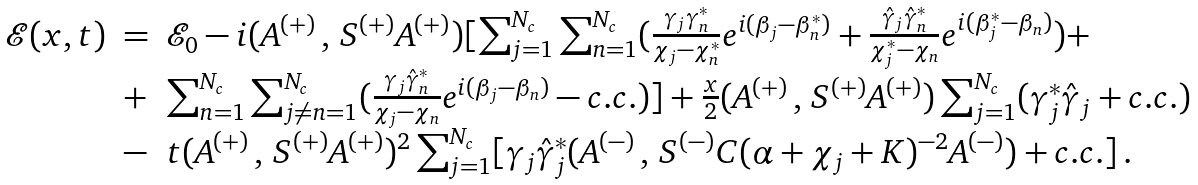<formula> <loc_0><loc_0><loc_500><loc_500>\begin{array} { l l l } \mathcal { E } ( x , t ) & = & \mathcal { E } _ { 0 } - i ( A ^ { ( + ) } \, , \, S ^ { ( + ) } A ^ { ( + ) } ) [ \sum _ { j = 1 } ^ { N _ { c } } \sum _ { n = 1 } ^ { N _ { c } } ( \frac { \gamma _ { j } \gamma _ { n } ^ { * } } { \chi _ { j } - \chi _ { n } ^ { * } } e ^ { i ( \beta _ { j } - \beta _ { n } ^ { * } ) } + \frac { \hat { \gamma } _ { j } \hat { \gamma } _ { n } ^ { * } } { \chi _ { j } ^ { * } - \chi _ { n } } e ^ { i ( \beta ^ { * } _ { j } - \beta _ { n } ) } ) + \\ & + & \sum _ { n = 1 } ^ { N _ { c } } \sum _ { j \neq n = 1 } ^ { N _ { c } } ( \frac { \gamma _ { j } \hat { \gamma } _ { n } ^ { * } } { \chi _ { j } - \chi _ { n } } e ^ { i ( \beta _ { j } - \beta _ { n } ) } - c . c . ) ] + \frac { x } { 2 } ( A ^ { ( + ) } \, , \, S ^ { ( + ) } A ^ { ( + ) } ) \sum _ { j = 1 } ^ { N _ { c } } ( \gamma _ { j } ^ { * } \hat { \gamma } _ { j } + c . c . ) \\ & - & t ( A ^ { ( + ) } \, , \, S ^ { ( + ) } A ^ { ( + ) } ) ^ { 2 } \sum _ { j = 1 } ^ { N _ { c } } [ \gamma _ { j } \hat { \gamma } ^ { * } _ { j } ( A ^ { ( - ) } \, , \, S ^ { ( - ) } C ( \alpha + \chi _ { j } + K ) ^ { - 2 } A ^ { ( - ) } ) + c . c . ] \, . \end{array}</formula> 